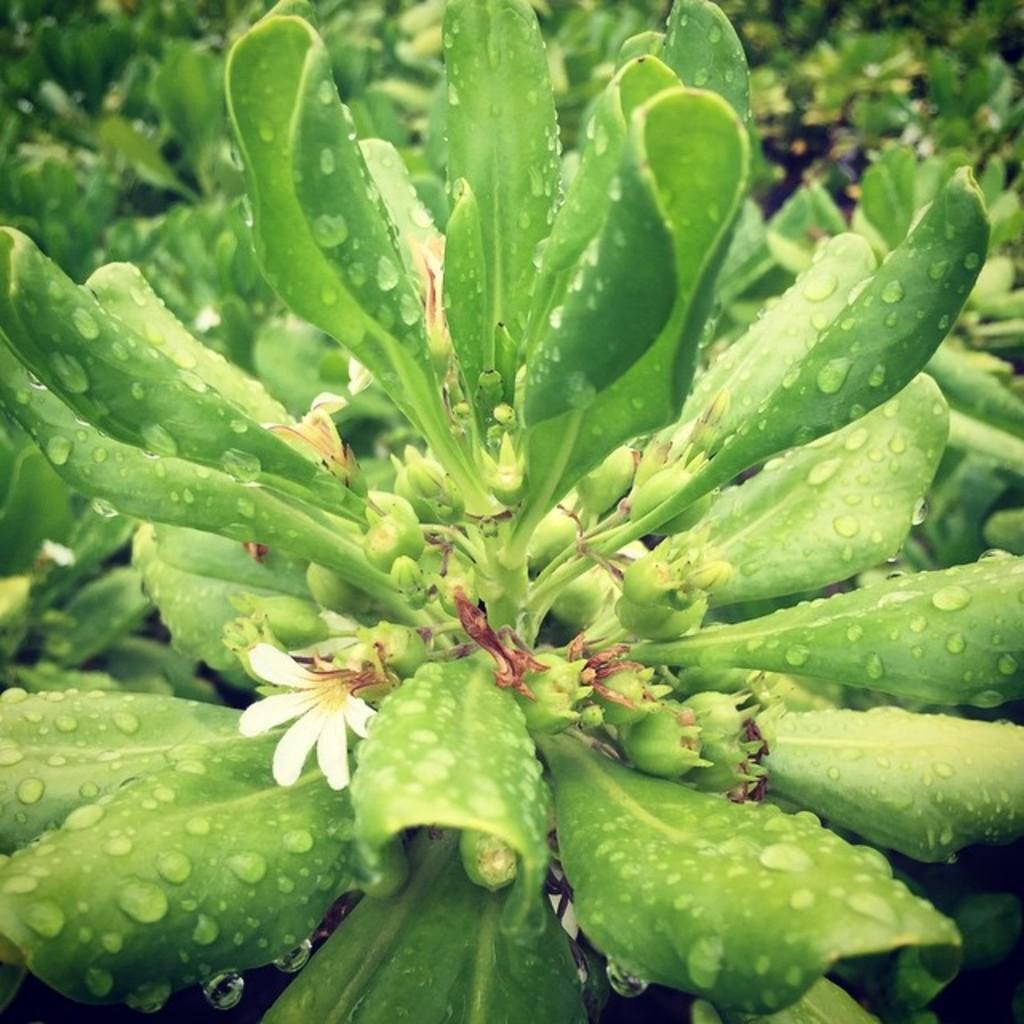Describe this image in one or two sentences. In this image, we can see a green color plant, there is a small white color flower on the plant. 